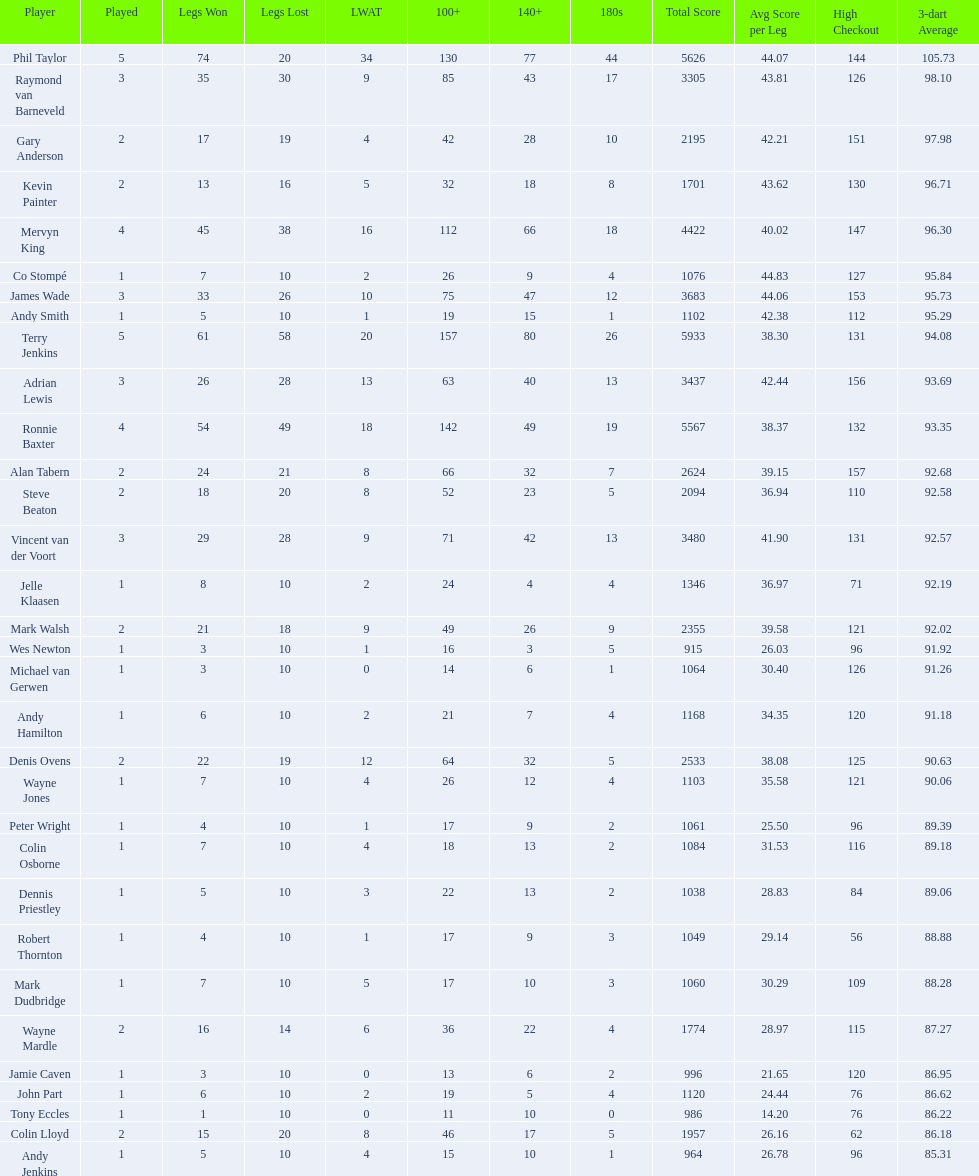What is the name of the next player after mark walsh? Wes Newton. 